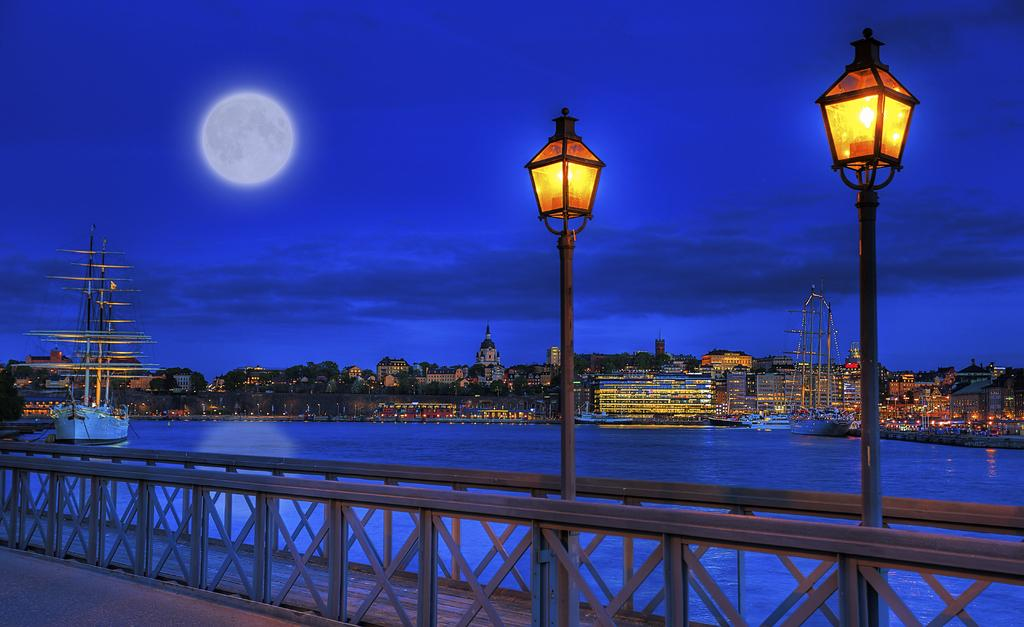What type of structure can be seen in the image? There is railing in the image, which suggests a structure like a bridge or a balcony. What are the light sources in the image? There are light poles in the image, which provide illumination. What can be seen in the background of the image? Boats, water, buildings, and trees are visible in the background of the image. What celestial body is visible in the sky? The moon is visible in the sky. Where is the goat located in the image? There is no goat present in the image. What type of tub is visible in the image? There is no tub present in the image. 